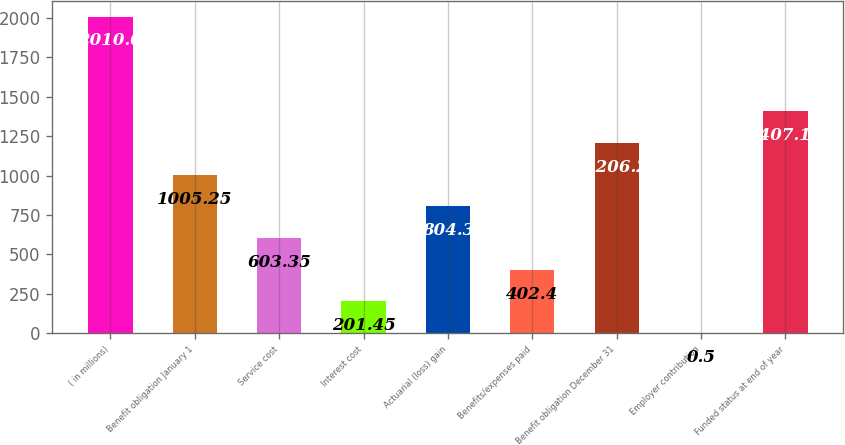Convert chart to OTSL. <chart><loc_0><loc_0><loc_500><loc_500><bar_chart><fcel>( in millions)<fcel>Benefit obligation January 1<fcel>Service cost<fcel>Interest cost<fcel>Actuarial (loss) gain<fcel>Benefits/expenses paid<fcel>Benefit obligation December 31<fcel>Employer contribution<fcel>Funded status at end of year<nl><fcel>2010<fcel>1005.25<fcel>603.35<fcel>201.45<fcel>804.3<fcel>402.4<fcel>1206.2<fcel>0.5<fcel>1407.15<nl></chart> 